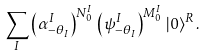<formula> <loc_0><loc_0><loc_500><loc_500>\sum _ { I } \left ( \alpha ^ { I } _ { - \theta _ { I } } \right ) ^ { N ^ { I } _ { 0 } } \, \left ( \psi ^ { I } _ { - \theta _ { I } } \right ) ^ { M ^ { I } _ { 0 } } \, | 0 \rangle ^ { R } \, .</formula> 